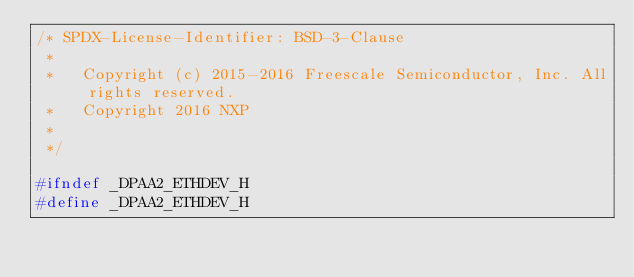<code> <loc_0><loc_0><loc_500><loc_500><_C_>/* SPDX-License-Identifier: BSD-3-Clause
 *
 *   Copyright (c) 2015-2016 Freescale Semiconductor, Inc. All rights reserved.
 *   Copyright 2016 NXP
 *
 */

#ifndef _DPAA2_ETHDEV_H
#define _DPAA2_ETHDEV_H
</code> 